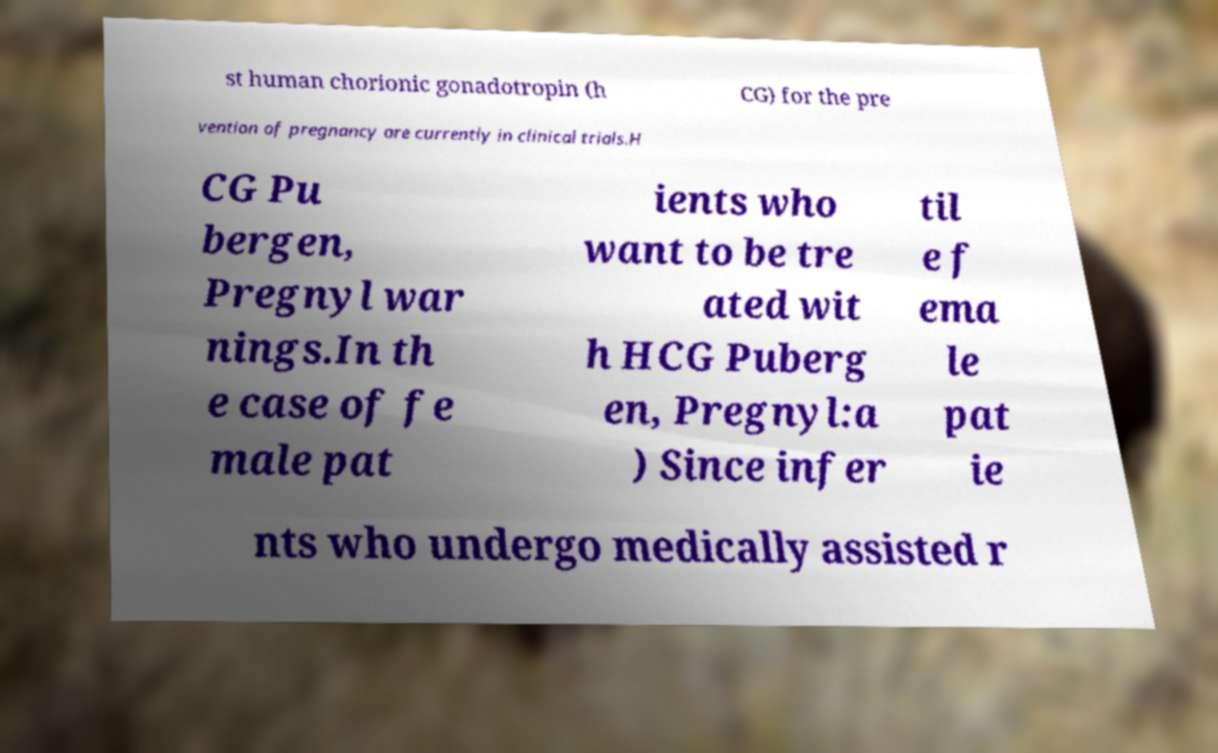Please read and relay the text visible in this image. What does it say? st human chorionic gonadotropin (h CG) for the pre vention of pregnancy are currently in clinical trials.H CG Pu bergen, Pregnyl war nings.In th e case of fe male pat ients who want to be tre ated wit h HCG Puberg en, Pregnyl:a ) Since infer til e f ema le pat ie nts who undergo medically assisted r 